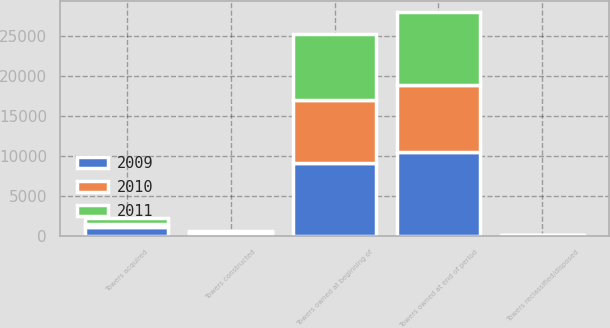Convert chart. <chart><loc_0><loc_0><loc_500><loc_500><stacked_bar_chart><ecel><fcel>Towers owned at beginning of<fcel>Towers acquired<fcel>Towers constructed<fcel>Towers reclassified/disposed<fcel>Towers owned at end of period<nl><fcel>2010<fcel>7854<fcel>376<fcel>101<fcel>7<fcel>8324<nl><fcel>2011<fcel>8324<fcel>712<fcel>124<fcel>49<fcel>9111<nl><fcel>2009<fcel>9111<fcel>1085<fcel>388<fcel>60<fcel>10524<nl></chart> 